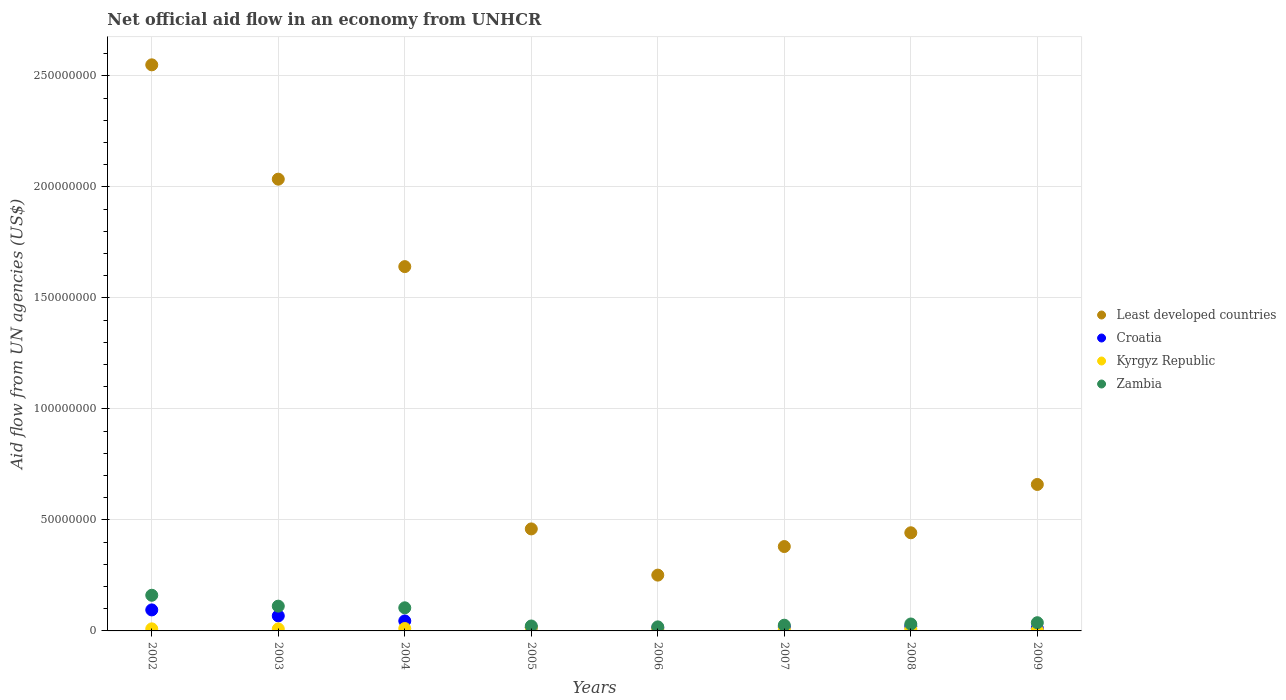How many different coloured dotlines are there?
Your answer should be very brief. 4. Is the number of dotlines equal to the number of legend labels?
Offer a very short reply. Yes. What is the net official aid flow in Kyrgyz Republic in 2002?
Your response must be concise. 9.30e+05. Across all years, what is the maximum net official aid flow in Least developed countries?
Your answer should be very brief. 2.55e+08. What is the total net official aid flow in Least developed countries in the graph?
Keep it short and to the point. 8.42e+08. What is the difference between the net official aid flow in Zambia in 2003 and that in 2009?
Your response must be concise. 7.46e+06. What is the difference between the net official aid flow in Croatia in 2002 and the net official aid flow in Zambia in 2009?
Your response must be concise. 5.76e+06. What is the average net official aid flow in Kyrgyz Republic per year?
Offer a terse response. 8.65e+05. In the year 2006, what is the difference between the net official aid flow in Least developed countries and net official aid flow in Croatia?
Make the answer very short. 2.38e+07. In how many years, is the net official aid flow in Croatia greater than 90000000 US$?
Keep it short and to the point. 0. What is the ratio of the net official aid flow in Least developed countries in 2008 to that in 2009?
Offer a very short reply. 0.67. Is the net official aid flow in Kyrgyz Republic in 2002 less than that in 2009?
Make the answer very short. No. Is the difference between the net official aid flow in Least developed countries in 2003 and 2006 greater than the difference between the net official aid flow in Croatia in 2003 and 2006?
Your answer should be compact. Yes. What is the difference between the highest and the second highest net official aid flow in Croatia?
Your response must be concise. 2.69e+06. What is the difference between the highest and the lowest net official aid flow in Least developed countries?
Your answer should be very brief. 2.30e+08. In how many years, is the net official aid flow in Least developed countries greater than the average net official aid flow in Least developed countries taken over all years?
Ensure brevity in your answer.  3. Is the sum of the net official aid flow in Zambia in 2005 and 2007 greater than the maximum net official aid flow in Croatia across all years?
Ensure brevity in your answer.  No. Does the net official aid flow in Least developed countries monotonically increase over the years?
Offer a very short reply. No. Is the net official aid flow in Croatia strictly less than the net official aid flow in Kyrgyz Republic over the years?
Your answer should be compact. No. How many years are there in the graph?
Keep it short and to the point. 8. What is the difference between two consecutive major ticks on the Y-axis?
Provide a short and direct response. 5.00e+07. Where does the legend appear in the graph?
Offer a terse response. Center right. How are the legend labels stacked?
Ensure brevity in your answer.  Vertical. What is the title of the graph?
Provide a succinct answer. Net official aid flow in an economy from UNHCR. Does "Bangladesh" appear as one of the legend labels in the graph?
Your response must be concise. No. What is the label or title of the X-axis?
Keep it short and to the point. Years. What is the label or title of the Y-axis?
Offer a very short reply. Aid flow from UN agencies (US$). What is the Aid flow from UN agencies (US$) of Least developed countries in 2002?
Keep it short and to the point. 2.55e+08. What is the Aid flow from UN agencies (US$) in Croatia in 2002?
Make the answer very short. 9.46e+06. What is the Aid flow from UN agencies (US$) in Kyrgyz Republic in 2002?
Keep it short and to the point. 9.30e+05. What is the Aid flow from UN agencies (US$) in Zambia in 2002?
Keep it short and to the point. 1.61e+07. What is the Aid flow from UN agencies (US$) of Least developed countries in 2003?
Your answer should be compact. 2.03e+08. What is the Aid flow from UN agencies (US$) of Croatia in 2003?
Ensure brevity in your answer.  6.77e+06. What is the Aid flow from UN agencies (US$) of Kyrgyz Republic in 2003?
Provide a succinct answer. 9.00e+05. What is the Aid flow from UN agencies (US$) in Zambia in 2003?
Make the answer very short. 1.12e+07. What is the Aid flow from UN agencies (US$) in Least developed countries in 2004?
Offer a terse response. 1.64e+08. What is the Aid flow from UN agencies (US$) in Croatia in 2004?
Provide a short and direct response. 4.50e+06. What is the Aid flow from UN agencies (US$) of Kyrgyz Republic in 2004?
Keep it short and to the point. 1.08e+06. What is the Aid flow from UN agencies (US$) in Zambia in 2004?
Your response must be concise. 1.04e+07. What is the Aid flow from UN agencies (US$) in Least developed countries in 2005?
Ensure brevity in your answer.  4.59e+07. What is the Aid flow from UN agencies (US$) in Croatia in 2005?
Your answer should be very brief. 1.61e+06. What is the Aid flow from UN agencies (US$) in Kyrgyz Republic in 2005?
Keep it short and to the point. 1.47e+06. What is the Aid flow from UN agencies (US$) in Zambia in 2005?
Make the answer very short. 2.22e+06. What is the Aid flow from UN agencies (US$) in Least developed countries in 2006?
Ensure brevity in your answer.  2.51e+07. What is the Aid flow from UN agencies (US$) in Croatia in 2006?
Provide a succinct answer. 1.38e+06. What is the Aid flow from UN agencies (US$) in Kyrgyz Republic in 2006?
Your response must be concise. 7.10e+05. What is the Aid flow from UN agencies (US$) of Zambia in 2006?
Offer a very short reply. 1.82e+06. What is the Aid flow from UN agencies (US$) of Least developed countries in 2007?
Make the answer very short. 3.80e+07. What is the Aid flow from UN agencies (US$) in Croatia in 2007?
Offer a very short reply. 1.78e+06. What is the Aid flow from UN agencies (US$) of Kyrgyz Republic in 2007?
Your answer should be very brief. 6.50e+05. What is the Aid flow from UN agencies (US$) in Zambia in 2007?
Keep it short and to the point. 2.58e+06. What is the Aid flow from UN agencies (US$) of Least developed countries in 2008?
Offer a very short reply. 4.42e+07. What is the Aid flow from UN agencies (US$) of Croatia in 2008?
Keep it short and to the point. 2.11e+06. What is the Aid flow from UN agencies (US$) of Kyrgyz Republic in 2008?
Provide a short and direct response. 8.20e+05. What is the Aid flow from UN agencies (US$) of Zambia in 2008?
Make the answer very short. 3.12e+06. What is the Aid flow from UN agencies (US$) in Least developed countries in 2009?
Ensure brevity in your answer.  6.60e+07. What is the Aid flow from UN agencies (US$) of Croatia in 2009?
Provide a short and direct response. 1.18e+06. What is the Aid flow from UN agencies (US$) in Zambia in 2009?
Provide a short and direct response. 3.70e+06. Across all years, what is the maximum Aid flow from UN agencies (US$) of Least developed countries?
Make the answer very short. 2.55e+08. Across all years, what is the maximum Aid flow from UN agencies (US$) in Croatia?
Keep it short and to the point. 9.46e+06. Across all years, what is the maximum Aid flow from UN agencies (US$) in Kyrgyz Republic?
Give a very brief answer. 1.47e+06. Across all years, what is the maximum Aid flow from UN agencies (US$) in Zambia?
Make the answer very short. 1.61e+07. Across all years, what is the minimum Aid flow from UN agencies (US$) in Least developed countries?
Your answer should be compact. 2.51e+07. Across all years, what is the minimum Aid flow from UN agencies (US$) in Croatia?
Provide a succinct answer. 1.18e+06. Across all years, what is the minimum Aid flow from UN agencies (US$) of Kyrgyz Republic?
Your answer should be compact. 3.60e+05. Across all years, what is the minimum Aid flow from UN agencies (US$) in Zambia?
Offer a terse response. 1.82e+06. What is the total Aid flow from UN agencies (US$) of Least developed countries in the graph?
Your answer should be compact. 8.42e+08. What is the total Aid flow from UN agencies (US$) in Croatia in the graph?
Make the answer very short. 2.88e+07. What is the total Aid flow from UN agencies (US$) of Kyrgyz Republic in the graph?
Keep it short and to the point. 6.92e+06. What is the total Aid flow from UN agencies (US$) of Zambia in the graph?
Your response must be concise. 5.11e+07. What is the difference between the Aid flow from UN agencies (US$) in Least developed countries in 2002 and that in 2003?
Your answer should be very brief. 5.15e+07. What is the difference between the Aid flow from UN agencies (US$) of Croatia in 2002 and that in 2003?
Your response must be concise. 2.69e+06. What is the difference between the Aid flow from UN agencies (US$) in Kyrgyz Republic in 2002 and that in 2003?
Give a very brief answer. 3.00e+04. What is the difference between the Aid flow from UN agencies (US$) of Zambia in 2002 and that in 2003?
Ensure brevity in your answer.  4.90e+06. What is the difference between the Aid flow from UN agencies (US$) in Least developed countries in 2002 and that in 2004?
Make the answer very short. 9.09e+07. What is the difference between the Aid flow from UN agencies (US$) in Croatia in 2002 and that in 2004?
Offer a very short reply. 4.96e+06. What is the difference between the Aid flow from UN agencies (US$) of Kyrgyz Republic in 2002 and that in 2004?
Provide a short and direct response. -1.50e+05. What is the difference between the Aid flow from UN agencies (US$) in Zambia in 2002 and that in 2004?
Make the answer very short. 5.65e+06. What is the difference between the Aid flow from UN agencies (US$) of Least developed countries in 2002 and that in 2005?
Offer a terse response. 2.09e+08. What is the difference between the Aid flow from UN agencies (US$) of Croatia in 2002 and that in 2005?
Give a very brief answer. 7.85e+06. What is the difference between the Aid flow from UN agencies (US$) in Kyrgyz Republic in 2002 and that in 2005?
Your answer should be compact. -5.40e+05. What is the difference between the Aid flow from UN agencies (US$) in Zambia in 2002 and that in 2005?
Provide a short and direct response. 1.38e+07. What is the difference between the Aid flow from UN agencies (US$) of Least developed countries in 2002 and that in 2006?
Offer a very short reply. 2.30e+08. What is the difference between the Aid flow from UN agencies (US$) in Croatia in 2002 and that in 2006?
Ensure brevity in your answer.  8.08e+06. What is the difference between the Aid flow from UN agencies (US$) in Kyrgyz Republic in 2002 and that in 2006?
Offer a very short reply. 2.20e+05. What is the difference between the Aid flow from UN agencies (US$) of Zambia in 2002 and that in 2006?
Ensure brevity in your answer.  1.42e+07. What is the difference between the Aid flow from UN agencies (US$) of Least developed countries in 2002 and that in 2007?
Keep it short and to the point. 2.17e+08. What is the difference between the Aid flow from UN agencies (US$) in Croatia in 2002 and that in 2007?
Offer a very short reply. 7.68e+06. What is the difference between the Aid flow from UN agencies (US$) of Zambia in 2002 and that in 2007?
Make the answer very short. 1.35e+07. What is the difference between the Aid flow from UN agencies (US$) in Least developed countries in 2002 and that in 2008?
Your response must be concise. 2.11e+08. What is the difference between the Aid flow from UN agencies (US$) in Croatia in 2002 and that in 2008?
Your answer should be very brief. 7.35e+06. What is the difference between the Aid flow from UN agencies (US$) of Kyrgyz Republic in 2002 and that in 2008?
Provide a succinct answer. 1.10e+05. What is the difference between the Aid flow from UN agencies (US$) of Zambia in 2002 and that in 2008?
Your answer should be very brief. 1.29e+07. What is the difference between the Aid flow from UN agencies (US$) of Least developed countries in 2002 and that in 2009?
Your response must be concise. 1.89e+08. What is the difference between the Aid flow from UN agencies (US$) in Croatia in 2002 and that in 2009?
Give a very brief answer. 8.28e+06. What is the difference between the Aid flow from UN agencies (US$) of Kyrgyz Republic in 2002 and that in 2009?
Ensure brevity in your answer.  5.70e+05. What is the difference between the Aid flow from UN agencies (US$) in Zambia in 2002 and that in 2009?
Your answer should be very brief. 1.24e+07. What is the difference between the Aid flow from UN agencies (US$) in Least developed countries in 2003 and that in 2004?
Your answer should be compact. 3.94e+07. What is the difference between the Aid flow from UN agencies (US$) of Croatia in 2003 and that in 2004?
Offer a terse response. 2.27e+06. What is the difference between the Aid flow from UN agencies (US$) of Zambia in 2003 and that in 2004?
Give a very brief answer. 7.50e+05. What is the difference between the Aid flow from UN agencies (US$) in Least developed countries in 2003 and that in 2005?
Offer a terse response. 1.58e+08. What is the difference between the Aid flow from UN agencies (US$) in Croatia in 2003 and that in 2005?
Give a very brief answer. 5.16e+06. What is the difference between the Aid flow from UN agencies (US$) in Kyrgyz Republic in 2003 and that in 2005?
Keep it short and to the point. -5.70e+05. What is the difference between the Aid flow from UN agencies (US$) of Zambia in 2003 and that in 2005?
Provide a succinct answer. 8.94e+06. What is the difference between the Aid flow from UN agencies (US$) in Least developed countries in 2003 and that in 2006?
Your answer should be very brief. 1.78e+08. What is the difference between the Aid flow from UN agencies (US$) of Croatia in 2003 and that in 2006?
Make the answer very short. 5.39e+06. What is the difference between the Aid flow from UN agencies (US$) of Zambia in 2003 and that in 2006?
Provide a succinct answer. 9.34e+06. What is the difference between the Aid flow from UN agencies (US$) in Least developed countries in 2003 and that in 2007?
Ensure brevity in your answer.  1.65e+08. What is the difference between the Aid flow from UN agencies (US$) of Croatia in 2003 and that in 2007?
Your response must be concise. 4.99e+06. What is the difference between the Aid flow from UN agencies (US$) in Kyrgyz Republic in 2003 and that in 2007?
Make the answer very short. 2.50e+05. What is the difference between the Aid flow from UN agencies (US$) in Zambia in 2003 and that in 2007?
Offer a terse response. 8.58e+06. What is the difference between the Aid flow from UN agencies (US$) in Least developed countries in 2003 and that in 2008?
Provide a short and direct response. 1.59e+08. What is the difference between the Aid flow from UN agencies (US$) of Croatia in 2003 and that in 2008?
Offer a very short reply. 4.66e+06. What is the difference between the Aid flow from UN agencies (US$) in Zambia in 2003 and that in 2008?
Offer a very short reply. 8.04e+06. What is the difference between the Aid flow from UN agencies (US$) of Least developed countries in 2003 and that in 2009?
Offer a terse response. 1.37e+08. What is the difference between the Aid flow from UN agencies (US$) of Croatia in 2003 and that in 2009?
Keep it short and to the point. 5.59e+06. What is the difference between the Aid flow from UN agencies (US$) in Kyrgyz Republic in 2003 and that in 2009?
Give a very brief answer. 5.40e+05. What is the difference between the Aid flow from UN agencies (US$) in Zambia in 2003 and that in 2009?
Offer a terse response. 7.46e+06. What is the difference between the Aid flow from UN agencies (US$) of Least developed countries in 2004 and that in 2005?
Give a very brief answer. 1.18e+08. What is the difference between the Aid flow from UN agencies (US$) of Croatia in 2004 and that in 2005?
Keep it short and to the point. 2.89e+06. What is the difference between the Aid flow from UN agencies (US$) of Kyrgyz Republic in 2004 and that in 2005?
Provide a succinct answer. -3.90e+05. What is the difference between the Aid flow from UN agencies (US$) in Zambia in 2004 and that in 2005?
Provide a succinct answer. 8.19e+06. What is the difference between the Aid flow from UN agencies (US$) in Least developed countries in 2004 and that in 2006?
Provide a succinct answer. 1.39e+08. What is the difference between the Aid flow from UN agencies (US$) of Croatia in 2004 and that in 2006?
Provide a short and direct response. 3.12e+06. What is the difference between the Aid flow from UN agencies (US$) of Zambia in 2004 and that in 2006?
Keep it short and to the point. 8.59e+06. What is the difference between the Aid flow from UN agencies (US$) of Least developed countries in 2004 and that in 2007?
Your response must be concise. 1.26e+08. What is the difference between the Aid flow from UN agencies (US$) in Croatia in 2004 and that in 2007?
Offer a very short reply. 2.72e+06. What is the difference between the Aid flow from UN agencies (US$) in Zambia in 2004 and that in 2007?
Keep it short and to the point. 7.83e+06. What is the difference between the Aid flow from UN agencies (US$) in Least developed countries in 2004 and that in 2008?
Make the answer very short. 1.20e+08. What is the difference between the Aid flow from UN agencies (US$) in Croatia in 2004 and that in 2008?
Your response must be concise. 2.39e+06. What is the difference between the Aid flow from UN agencies (US$) of Kyrgyz Republic in 2004 and that in 2008?
Make the answer very short. 2.60e+05. What is the difference between the Aid flow from UN agencies (US$) of Zambia in 2004 and that in 2008?
Give a very brief answer. 7.29e+06. What is the difference between the Aid flow from UN agencies (US$) in Least developed countries in 2004 and that in 2009?
Give a very brief answer. 9.81e+07. What is the difference between the Aid flow from UN agencies (US$) of Croatia in 2004 and that in 2009?
Your answer should be very brief. 3.32e+06. What is the difference between the Aid flow from UN agencies (US$) in Kyrgyz Republic in 2004 and that in 2009?
Offer a terse response. 7.20e+05. What is the difference between the Aid flow from UN agencies (US$) in Zambia in 2004 and that in 2009?
Ensure brevity in your answer.  6.71e+06. What is the difference between the Aid flow from UN agencies (US$) of Least developed countries in 2005 and that in 2006?
Provide a short and direct response. 2.08e+07. What is the difference between the Aid flow from UN agencies (US$) in Kyrgyz Republic in 2005 and that in 2006?
Provide a short and direct response. 7.60e+05. What is the difference between the Aid flow from UN agencies (US$) in Least developed countries in 2005 and that in 2007?
Offer a terse response. 7.94e+06. What is the difference between the Aid flow from UN agencies (US$) of Croatia in 2005 and that in 2007?
Provide a succinct answer. -1.70e+05. What is the difference between the Aid flow from UN agencies (US$) of Kyrgyz Republic in 2005 and that in 2007?
Provide a succinct answer. 8.20e+05. What is the difference between the Aid flow from UN agencies (US$) in Zambia in 2005 and that in 2007?
Your response must be concise. -3.60e+05. What is the difference between the Aid flow from UN agencies (US$) of Least developed countries in 2005 and that in 2008?
Keep it short and to the point. 1.74e+06. What is the difference between the Aid flow from UN agencies (US$) in Croatia in 2005 and that in 2008?
Your response must be concise. -5.00e+05. What is the difference between the Aid flow from UN agencies (US$) of Kyrgyz Republic in 2005 and that in 2008?
Give a very brief answer. 6.50e+05. What is the difference between the Aid flow from UN agencies (US$) of Zambia in 2005 and that in 2008?
Provide a succinct answer. -9.00e+05. What is the difference between the Aid flow from UN agencies (US$) of Least developed countries in 2005 and that in 2009?
Give a very brief answer. -2.00e+07. What is the difference between the Aid flow from UN agencies (US$) of Kyrgyz Republic in 2005 and that in 2009?
Keep it short and to the point. 1.11e+06. What is the difference between the Aid flow from UN agencies (US$) of Zambia in 2005 and that in 2009?
Provide a short and direct response. -1.48e+06. What is the difference between the Aid flow from UN agencies (US$) in Least developed countries in 2006 and that in 2007?
Offer a very short reply. -1.29e+07. What is the difference between the Aid flow from UN agencies (US$) in Croatia in 2006 and that in 2007?
Ensure brevity in your answer.  -4.00e+05. What is the difference between the Aid flow from UN agencies (US$) in Kyrgyz Republic in 2006 and that in 2007?
Provide a succinct answer. 6.00e+04. What is the difference between the Aid flow from UN agencies (US$) of Zambia in 2006 and that in 2007?
Provide a short and direct response. -7.60e+05. What is the difference between the Aid flow from UN agencies (US$) of Least developed countries in 2006 and that in 2008?
Ensure brevity in your answer.  -1.91e+07. What is the difference between the Aid flow from UN agencies (US$) in Croatia in 2006 and that in 2008?
Ensure brevity in your answer.  -7.30e+05. What is the difference between the Aid flow from UN agencies (US$) in Kyrgyz Republic in 2006 and that in 2008?
Your answer should be very brief. -1.10e+05. What is the difference between the Aid flow from UN agencies (US$) in Zambia in 2006 and that in 2008?
Keep it short and to the point. -1.30e+06. What is the difference between the Aid flow from UN agencies (US$) in Least developed countries in 2006 and that in 2009?
Give a very brief answer. -4.08e+07. What is the difference between the Aid flow from UN agencies (US$) in Croatia in 2006 and that in 2009?
Your response must be concise. 2.00e+05. What is the difference between the Aid flow from UN agencies (US$) in Zambia in 2006 and that in 2009?
Offer a very short reply. -1.88e+06. What is the difference between the Aid flow from UN agencies (US$) of Least developed countries in 2007 and that in 2008?
Your answer should be compact. -6.20e+06. What is the difference between the Aid flow from UN agencies (US$) in Croatia in 2007 and that in 2008?
Give a very brief answer. -3.30e+05. What is the difference between the Aid flow from UN agencies (US$) of Zambia in 2007 and that in 2008?
Give a very brief answer. -5.40e+05. What is the difference between the Aid flow from UN agencies (US$) in Least developed countries in 2007 and that in 2009?
Offer a terse response. -2.80e+07. What is the difference between the Aid flow from UN agencies (US$) in Kyrgyz Republic in 2007 and that in 2009?
Give a very brief answer. 2.90e+05. What is the difference between the Aid flow from UN agencies (US$) of Zambia in 2007 and that in 2009?
Give a very brief answer. -1.12e+06. What is the difference between the Aid flow from UN agencies (US$) in Least developed countries in 2008 and that in 2009?
Ensure brevity in your answer.  -2.18e+07. What is the difference between the Aid flow from UN agencies (US$) in Croatia in 2008 and that in 2009?
Offer a terse response. 9.30e+05. What is the difference between the Aid flow from UN agencies (US$) in Zambia in 2008 and that in 2009?
Make the answer very short. -5.80e+05. What is the difference between the Aid flow from UN agencies (US$) of Least developed countries in 2002 and the Aid flow from UN agencies (US$) of Croatia in 2003?
Give a very brief answer. 2.48e+08. What is the difference between the Aid flow from UN agencies (US$) of Least developed countries in 2002 and the Aid flow from UN agencies (US$) of Kyrgyz Republic in 2003?
Give a very brief answer. 2.54e+08. What is the difference between the Aid flow from UN agencies (US$) of Least developed countries in 2002 and the Aid flow from UN agencies (US$) of Zambia in 2003?
Provide a succinct answer. 2.44e+08. What is the difference between the Aid flow from UN agencies (US$) in Croatia in 2002 and the Aid flow from UN agencies (US$) in Kyrgyz Republic in 2003?
Provide a short and direct response. 8.56e+06. What is the difference between the Aid flow from UN agencies (US$) of Croatia in 2002 and the Aid flow from UN agencies (US$) of Zambia in 2003?
Keep it short and to the point. -1.70e+06. What is the difference between the Aid flow from UN agencies (US$) of Kyrgyz Republic in 2002 and the Aid flow from UN agencies (US$) of Zambia in 2003?
Ensure brevity in your answer.  -1.02e+07. What is the difference between the Aid flow from UN agencies (US$) of Least developed countries in 2002 and the Aid flow from UN agencies (US$) of Croatia in 2004?
Keep it short and to the point. 2.50e+08. What is the difference between the Aid flow from UN agencies (US$) of Least developed countries in 2002 and the Aid flow from UN agencies (US$) of Kyrgyz Republic in 2004?
Your response must be concise. 2.54e+08. What is the difference between the Aid flow from UN agencies (US$) of Least developed countries in 2002 and the Aid flow from UN agencies (US$) of Zambia in 2004?
Ensure brevity in your answer.  2.45e+08. What is the difference between the Aid flow from UN agencies (US$) of Croatia in 2002 and the Aid flow from UN agencies (US$) of Kyrgyz Republic in 2004?
Your response must be concise. 8.38e+06. What is the difference between the Aid flow from UN agencies (US$) in Croatia in 2002 and the Aid flow from UN agencies (US$) in Zambia in 2004?
Provide a short and direct response. -9.50e+05. What is the difference between the Aid flow from UN agencies (US$) of Kyrgyz Republic in 2002 and the Aid flow from UN agencies (US$) of Zambia in 2004?
Make the answer very short. -9.48e+06. What is the difference between the Aid flow from UN agencies (US$) in Least developed countries in 2002 and the Aid flow from UN agencies (US$) in Croatia in 2005?
Ensure brevity in your answer.  2.53e+08. What is the difference between the Aid flow from UN agencies (US$) of Least developed countries in 2002 and the Aid flow from UN agencies (US$) of Kyrgyz Republic in 2005?
Your answer should be very brief. 2.53e+08. What is the difference between the Aid flow from UN agencies (US$) of Least developed countries in 2002 and the Aid flow from UN agencies (US$) of Zambia in 2005?
Make the answer very short. 2.53e+08. What is the difference between the Aid flow from UN agencies (US$) in Croatia in 2002 and the Aid flow from UN agencies (US$) in Kyrgyz Republic in 2005?
Make the answer very short. 7.99e+06. What is the difference between the Aid flow from UN agencies (US$) of Croatia in 2002 and the Aid flow from UN agencies (US$) of Zambia in 2005?
Provide a succinct answer. 7.24e+06. What is the difference between the Aid flow from UN agencies (US$) in Kyrgyz Republic in 2002 and the Aid flow from UN agencies (US$) in Zambia in 2005?
Ensure brevity in your answer.  -1.29e+06. What is the difference between the Aid flow from UN agencies (US$) of Least developed countries in 2002 and the Aid flow from UN agencies (US$) of Croatia in 2006?
Give a very brief answer. 2.54e+08. What is the difference between the Aid flow from UN agencies (US$) in Least developed countries in 2002 and the Aid flow from UN agencies (US$) in Kyrgyz Republic in 2006?
Provide a short and direct response. 2.54e+08. What is the difference between the Aid flow from UN agencies (US$) of Least developed countries in 2002 and the Aid flow from UN agencies (US$) of Zambia in 2006?
Provide a succinct answer. 2.53e+08. What is the difference between the Aid flow from UN agencies (US$) in Croatia in 2002 and the Aid flow from UN agencies (US$) in Kyrgyz Republic in 2006?
Make the answer very short. 8.75e+06. What is the difference between the Aid flow from UN agencies (US$) in Croatia in 2002 and the Aid flow from UN agencies (US$) in Zambia in 2006?
Offer a very short reply. 7.64e+06. What is the difference between the Aid flow from UN agencies (US$) in Kyrgyz Republic in 2002 and the Aid flow from UN agencies (US$) in Zambia in 2006?
Your answer should be compact. -8.90e+05. What is the difference between the Aid flow from UN agencies (US$) of Least developed countries in 2002 and the Aid flow from UN agencies (US$) of Croatia in 2007?
Provide a short and direct response. 2.53e+08. What is the difference between the Aid flow from UN agencies (US$) in Least developed countries in 2002 and the Aid flow from UN agencies (US$) in Kyrgyz Republic in 2007?
Give a very brief answer. 2.54e+08. What is the difference between the Aid flow from UN agencies (US$) of Least developed countries in 2002 and the Aid flow from UN agencies (US$) of Zambia in 2007?
Your response must be concise. 2.52e+08. What is the difference between the Aid flow from UN agencies (US$) in Croatia in 2002 and the Aid flow from UN agencies (US$) in Kyrgyz Republic in 2007?
Give a very brief answer. 8.81e+06. What is the difference between the Aid flow from UN agencies (US$) in Croatia in 2002 and the Aid flow from UN agencies (US$) in Zambia in 2007?
Provide a succinct answer. 6.88e+06. What is the difference between the Aid flow from UN agencies (US$) of Kyrgyz Republic in 2002 and the Aid flow from UN agencies (US$) of Zambia in 2007?
Make the answer very short. -1.65e+06. What is the difference between the Aid flow from UN agencies (US$) of Least developed countries in 2002 and the Aid flow from UN agencies (US$) of Croatia in 2008?
Ensure brevity in your answer.  2.53e+08. What is the difference between the Aid flow from UN agencies (US$) in Least developed countries in 2002 and the Aid flow from UN agencies (US$) in Kyrgyz Republic in 2008?
Keep it short and to the point. 2.54e+08. What is the difference between the Aid flow from UN agencies (US$) of Least developed countries in 2002 and the Aid flow from UN agencies (US$) of Zambia in 2008?
Your answer should be compact. 2.52e+08. What is the difference between the Aid flow from UN agencies (US$) in Croatia in 2002 and the Aid flow from UN agencies (US$) in Kyrgyz Republic in 2008?
Your answer should be compact. 8.64e+06. What is the difference between the Aid flow from UN agencies (US$) of Croatia in 2002 and the Aid flow from UN agencies (US$) of Zambia in 2008?
Offer a very short reply. 6.34e+06. What is the difference between the Aid flow from UN agencies (US$) in Kyrgyz Republic in 2002 and the Aid flow from UN agencies (US$) in Zambia in 2008?
Keep it short and to the point. -2.19e+06. What is the difference between the Aid flow from UN agencies (US$) of Least developed countries in 2002 and the Aid flow from UN agencies (US$) of Croatia in 2009?
Provide a short and direct response. 2.54e+08. What is the difference between the Aid flow from UN agencies (US$) in Least developed countries in 2002 and the Aid flow from UN agencies (US$) in Kyrgyz Republic in 2009?
Your answer should be compact. 2.55e+08. What is the difference between the Aid flow from UN agencies (US$) of Least developed countries in 2002 and the Aid flow from UN agencies (US$) of Zambia in 2009?
Ensure brevity in your answer.  2.51e+08. What is the difference between the Aid flow from UN agencies (US$) of Croatia in 2002 and the Aid flow from UN agencies (US$) of Kyrgyz Republic in 2009?
Offer a terse response. 9.10e+06. What is the difference between the Aid flow from UN agencies (US$) of Croatia in 2002 and the Aid flow from UN agencies (US$) of Zambia in 2009?
Give a very brief answer. 5.76e+06. What is the difference between the Aid flow from UN agencies (US$) in Kyrgyz Republic in 2002 and the Aid flow from UN agencies (US$) in Zambia in 2009?
Provide a short and direct response. -2.77e+06. What is the difference between the Aid flow from UN agencies (US$) in Least developed countries in 2003 and the Aid flow from UN agencies (US$) in Croatia in 2004?
Your response must be concise. 1.99e+08. What is the difference between the Aid flow from UN agencies (US$) of Least developed countries in 2003 and the Aid flow from UN agencies (US$) of Kyrgyz Republic in 2004?
Provide a short and direct response. 2.02e+08. What is the difference between the Aid flow from UN agencies (US$) of Least developed countries in 2003 and the Aid flow from UN agencies (US$) of Zambia in 2004?
Make the answer very short. 1.93e+08. What is the difference between the Aid flow from UN agencies (US$) of Croatia in 2003 and the Aid flow from UN agencies (US$) of Kyrgyz Republic in 2004?
Offer a terse response. 5.69e+06. What is the difference between the Aid flow from UN agencies (US$) in Croatia in 2003 and the Aid flow from UN agencies (US$) in Zambia in 2004?
Your response must be concise. -3.64e+06. What is the difference between the Aid flow from UN agencies (US$) of Kyrgyz Republic in 2003 and the Aid flow from UN agencies (US$) of Zambia in 2004?
Keep it short and to the point. -9.51e+06. What is the difference between the Aid flow from UN agencies (US$) of Least developed countries in 2003 and the Aid flow from UN agencies (US$) of Croatia in 2005?
Keep it short and to the point. 2.02e+08. What is the difference between the Aid flow from UN agencies (US$) of Least developed countries in 2003 and the Aid flow from UN agencies (US$) of Kyrgyz Republic in 2005?
Your answer should be compact. 2.02e+08. What is the difference between the Aid flow from UN agencies (US$) of Least developed countries in 2003 and the Aid flow from UN agencies (US$) of Zambia in 2005?
Make the answer very short. 2.01e+08. What is the difference between the Aid flow from UN agencies (US$) in Croatia in 2003 and the Aid flow from UN agencies (US$) in Kyrgyz Republic in 2005?
Ensure brevity in your answer.  5.30e+06. What is the difference between the Aid flow from UN agencies (US$) of Croatia in 2003 and the Aid flow from UN agencies (US$) of Zambia in 2005?
Provide a short and direct response. 4.55e+06. What is the difference between the Aid flow from UN agencies (US$) in Kyrgyz Republic in 2003 and the Aid flow from UN agencies (US$) in Zambia in 2005?
Offer a very short reply. -1.32e+06. What is the difference between the Aid flow from UN agencies (US$) of Least developed countries in 2003 and the Aid flow from UN agencies (US$) of Croatia in 2006?
Give a very brief answer. 2.02e+08. What is the difference between the Aid flow from UN agencies (US$) of Least developed countries in 2003 and the Aid flow from UN agencies (US$) of Kyrgyz Republic in 2006?
Your response must be concise. 2.03e+08. What is the difference between the Aid flow from UN agencies (US$) of Least developed countries in 2003 and the Aid flow from UN agencies (US$) of Zambia in 2006?
Your answer should be compact. 2.02e+08. What is the difference between the Aid flow from UN agencies (US$) of Croatia in 2003 and the Aid flow from UN agencies (US$) of Kyrgyz Republic in 2006?
Your response must be concise. 6.06e+06. What is the difference between the Aid flow from UN agencies (US$) of Croatia in 2003 and the Aid flow from UN agencies (US$) of Zambia in 2006?
Offer a very short reply. 4.95e+06. What is the difference between the Aid flow from UN agencies (US$) of Kyrgyz Republic in 2003 and the Aid flow from UN agencies (US$) of Zambia in 2006?
Provide a succinct answer. -9.20e+05. What is the difference between the Aid flow from UN agencies (US$) of Least developed countries in 2003 and the Aid flow from UN agencies (US$) of Croatia in 2007?
Provide a succinct answer. 2.02e+08. What is the difference between the Aid flow from UN agencies (US$) of Least developed countries in 2003 and the Aid flow from UN agencies (US$) of Kyrgyz Republic in 2007?
Provide a succinct answer. 2.03e+08. What is the difference between the Aid flow from UN agencies (US$) in Least developed countries in 2003 and the Aid flow from UN agencies (US$) in Zambia in 2007?
Offer a terse response. 2.01e+08. What is the difference between the Aid flow from UN agencies (US$) of Croatia in 2003 and the Aid flow from UN agencies (US$) of Kyrgyz Republic in 2007?
Offer a terse response. 6.12e+06. What is the difference between the Aid flow from UN agencies (US$) of Croatia in 2003 and the Aid flow from UN agencies (US$) of Zambia in 2007?
Ensure brevity in your answer.  4.19e+06. What is the difference between the Aid flow from UN agencies (US$) of Kyrgyz Republic in 2003 and the Aid flow from UN agencies (US$) of Zambia in 2007?
Give a very brief answer. -1.68e+06. What is the difference between the Aid flow from UN agencies (US$) in Least developed countries in 2003 and the Aid flow from UN agencies (US$) in Croatia in 2008?
Provide a short and direct response. 2.01e+08. What is the difference between the Aid flow from UN agencies (US$) in Least developed countries in 2003 and the Aid flow from UN agencies (US$) in Kyrgyz Republic in 2008?
Your answer should be very brief. 2.03e+08. What is the difference between the Aid flow from UN agencies (US$) in Least developed countries in 2003 and the Aid flow from UN agencies (US$) in Zambia in 2008?
Your response must be concise. 2.00e+08. What is the difference between the Aid flow from UN agencies (US$) of Croatia in 2003 and the Aid flow from UN agencies (US$) of Kyrgyz Republic in 2008?
Your response must be concise. 5.95e+06. What is the difference between the Aid flow from UN agencies (US$) in Croatia in 2003 and the Aid flow from UN agencies (US$) in Zambia in 2008?
Give a very brief answer. 3.65e+06. What is the difference between the Aid flow from UN agencies (US$) in Kyrgyz Republic in 2003 and the Aid flow from UN agencies (US$) in Zambia in 2008?
Offer a very short reply. -2.22e+06. What is the difference between the Aid flow from UN agencies (US$) of Least developed countries in 2003 and the Aid flow from UN agencies (US$) of Croatia in 2009?
Provide a succinct answer. 2.02e+08. What is the difference between the Aid flow from UN agencies (US$) of Least developed countries in 2003 and the Aid flow from UN agencies (US$) of Kyrgyz Republic in 2009?
Offer a terse response. 2.03e+08. What is the difference between the Aid flow from UN agencies (US$) in Least developed countries in 2003 and the Aid flow from UN agencies (US$) in Zambia in 2009?
Ensure brevity in your answer.  2.00e+08. What is the difference between the Aid flow from UN agencies (US$) in Croatia in 2003 and the Aid flow from UN agencies (US$) in Kyrgyz Republic in 2009?
Offer a very short reply. 6.41e+06. What is the difference between the Aid flow from UN agencies (US$) in Croatia in 2003 and the Aid flow from UN agencies (US$) in Zambia in 2009?
Give a very brief answer. 3.07e+06. What is the difference between the Aid flow from UN agencies (US$) in Kyrgyz Republic in 2003 and the Aid flow from UN agencies (US$) in Zambia in 2009?
Give a very brief answer. -2.80e+06. What is the difference between the Aid flow from UN agencies (US$) of Least developed countries in 2004 and the Aid flow from UN agencies (US$) of Croatia in 2005?
Your answer should be very brief. 1.62e+08. What is the difference between the Aid flow from UN agencies (US$) in Least developed countries in 2004 and the Aid flow from UN agencies (US$) in Kyrgyz Republic in 2005?
Offer a very short reply. 1.63e+08. What is the difference between the Aid flow from UN agencies (US$) in Least developed countries in 2004 and the Aid flow from UN agencies (US$) in Zambia in 2005?
Provide a succinct answer. 1.62e+08. What is the difference between the Aid flow from UN agencies (US$) in Croatia in 2004 and the Aid flow from UN agencies (US$) in Kyrgyz Republic in 2005?
Your answer should be very brief. 3.03e+06. What is the difference between the Aid flow from UN agencies (US$) of Croatia in 2004 and the Aid flow from UN agencies (US$) of Zambia in 2005?
Your answer should be very brief. 2.28e+06. What is the difference between the Aid flow from UN agencies (US$) of Kyrgyz Republic in 2004 and the Aid flow from UN agencies (US$) of Zambia in 2005?
Your answer should be very brief. -1.14e+06. What is the difference between the Aid flow from UN agencies (US$) of Least developed countries in 2004 and the Aid flow from UN agencies (US$) of Croatia in 2006?
Ensure brevity in your answer.  1.63e+08. What is the difference between the Aid flow from UN agencies (US$) of Least developed countries in 2004 and the Aid flow from UN agencies (US$) of Kyrgyz Republic in 2006?
Offer a terse response. 1.63e+08. What is the difference between the Aid flow from UN agencies (US$) in Least developed countries in 2004 and the Aid flow from UN agencies (US$) in Zambia in 2006?
Your answer should be compact. 1.62e+08. What is the difference between the Aid flow from UN agencies (US$) of Croatia in 2004 and the Aid flow from UN agencies (US$) of Kyrgyz Republic in 2006?
Give a very brief answer. 3.79e+06. What is the difference between the Aid flow from UN agencies (US$) in Croatia in 2004 and the Aid flow from UN agencies (US$) in Zambia in 2006?
Make the answer very short. 2.68e+06. What is the difference between the Aid flow from UN agencies (US$) in Kyrgyz Republic in 2004 and the Aid flow from UN agencies (US$) in Zambia in 2006?
Ensure brevity in your answer.  -7.40e+05. What is the difference between the Aid flow from UN agencies (US$) in Least developed countries in 2004 and the Aid flow from UN agencies (US$) in Croatia in 2007?
Your response must be concise. 1.62e+08. What is the difference between the Aid flow from UN agencies (US$) of Least developed countries in 2004 and the Aid flow from UN agencies (US$) of Kyrgyz Republic in 2007?
Ensure brevity in your answer.  1.63e+08. What is the difference between the Aid flow from UN agencies (US$) in Least developed countries in 2004 and the Aid flow from UN agencies (US$) in Zambia in 2007?
Your answer should be very brief. 1.61e+08. What is the difference between the Aid flow from UN agencies (US$) in Croatia in 2004 and the Aid flow from UN agencies (US$) in Kyrgyz Republic in 2007?
Give a very brief answer. 3.85e+06. What is the difference between the Aid flow from UN agencies (US$) in Croatia in 2004 and the Aid flow from UN agencies (US$) in Zambia in 2007?
Provide a succinct answer. 1.92e+06. What is the difference between the Aid flow from UN agencies (US$) in Kyrgyz Republic in 2004 and the Aid flow from UN agencies (US$) in Zambia in 2007?
Provide a succinct answer. -1.50e+06. What is the difference between the Aid flow from UN agencies (US$) of Least developed countries in 2004 and the Aid flow from UN agencies (US$) of Croatia in 2008?
Provide a succinct answer. 1.62e+08. What is the difference between the Aid flow from UN agencies (US$) in Least developed countries in 2004 and the Aid flow from UN agencies (US$) in Kyrgyz Republic in 2008?
Your answer should be compact. 1.63e+08. What is the difference between the Aid flow from UN agencies (US$) in Least developed countries in 2004 and the Aid flow from UN agencies (US$) in Zambia in 2008?
Give a very brief answer. 1.61e+08. What is the difference between the Aid flow from UN agencies (US$) in Croatia in 2004 and the Aid flow from UN agencies (US$) in Kyrgyz Republic in 2008?
Make the answer very short. 3.68e+06. What is the difference between the Aid flow from UN agencies (US$) in Croatia in 2004 and the Aid flow from UN agencies (US$) in Zambia in 2008?
Ensure brevity in your answer.  1.38e+06. What is the difference between the Aid flow from UN agencies (US$) in Kyrgyz Republic in 2004 and the Aid flow from UN agencies (US$) in Zambia in 2008?
Offer a very short reply. -2.04e+06. What is the difference between the Aid flow from UN agencies (US$) of Least developed countries in 2004 and the Aid flow from UN agencies (US$) of Croatia in 2009?
Offer a terse response. 1.63e+08. What is the difference between the Aid flow from UN agencies (US$) in Least developed countries in 2004 and the Aid flow from UN agencies (US$) in Kyrgyz Republic in 2009?
Make the answer very short. 1.64e+08. What is the difference between the Aid flow from UN agencies (US$) in Least developed countries in 2004 and the Aid flow from UN agencies (US$) in Zambia in 2009?
Offer a very short reply. 1.60e+08. What is the difference between the Aid flow from UN agencies (US$) in Croatia in 2004 and the Aid flow from UN agencies (US$) in Kyrgyz Republic in 2009?
Offer a terse response. 4.14e+06. What is the difference between the Aid flow from UN agencies (US$) of Croatia in 2004 and the Aid flow from UN agencies (US$) of Zambia in 2009?
Your response must be concise. 8.00e+05. What is the difference between the Aid flow from UN agencies (US$) in Kyrgyz Republic in 2004 and the Aid flow from UN agencies (US$) in Zambia in 2009?
Provide a short and direct response. -2.62e+06. What is the difference between the Aid flow from UN agencies (US$) in Least developed countries in 2005 and the Aid flow from UN agencies (US$) in Croatia in 2006?
Give a very brief answer. 4.46e+07. What is the difference between the Aid flow from UN agencies (US$) of Least developed countries in 2005 and the Aid flow from UN agencies (US$) of Kyrgyz Republic in 2006?
Provide a short and direct response. 4.52e+07. What is the difference between the Aid flow from UN agencies (US$) of Least developed countries in 2005 and the Aid flow from UN agencies (US$) of Zambia in 2006?
Your response must be concise. 4.41e+07. What is the difference between the Aid flow from UN agencies (US$) of Croatia in 2005 and the Aid flow from UN agencies (US$) of Kyrgyz Republic in 2006?
Provide a succinct answer. 9.00e+05. What is the difference between the Aid flow from UN agencies (US$) in Kyrgyz Republic in 2005 and the Aid flow from UN agencies (US$) in Zambia in 2006?
Offer a terse response. -3.50e+05. What is the difference between the Aid flow from UN agencies (US$) of Least developed countries in 2005 and the Aid flow from UN agencies (US$) of Croatia in 2007?
Provide a succinct answer. 4.42e+07. What is the difference between the Aid flow from UN agencies (US$) of Least developed countries in 2005 and the Aid flow from UN agencies (US$) of Kyrgyz Republic in 2007?
Make the answer very short. 4.53e+07. What is the difference between the Aid flow from UN agencies (US$) of Least developed countries in 2005 and the Aid flow from UN agencies (US$) of Zambia in 2007?
Your response must be concise. 4.34e+07. What is the difference between the Aid flow from UN agencies (US$) in Croatia in 2005 and the Aid flow from UN agencies (US$) in Kyrgyz Republic in 2007?
Keep it short and to the point. 9.60e+05. What is the difference between the Aid flow from UN agencies (US$) of Croatia in 2005 and the Aid flow from UN agencies (US$) of Zambia in 2007?
Make the answer very short. -9.70e+05. What is the difference between the Aid flow from UN agencies (US$) of Kyrgyz Republic in 2005 and the Aid flow from UN agencies (US$) of Zambia in 2007?
Offer a very short reply. -1.11e+06. What is the difference between the Aid flow from UN agencies (US$) in Least developed countries in 2005 and the Aid flow from UN agencies (US$) in Croatia in 2008?
Offer a terse response. 4.38e+07. What is the difference between the Aid flow from UN agencies (US$) of Least developed countries in 2005 and the Aid flow from UN agencies (US$) of Kyrgyz Republic in 2008?
Give a very brief answer. 4.51e+07. What is the difference between the Aid flow from UN agencies (US$) of Least developed countries in 2005 and the Aid flow from UN agencies (US$) of Zambia in 2008?
Make the answer very short. 4.28e+07. What is the difference between the Aid flow from UN agencies (US$) of Croatia in 2005 and the Aid flow from UN agencies (US$) of Kyrgyz Republic in 2008?
Provide a short and direct response. 7.90e+05. What is the difference between the Aid flow from UN agencies (US$) in Croatia in 2005 and the Aid flow from UN agencies (US$) in Zambia in 2008?
Give a very brief answer. -1.51e+06. What is the difference between the Aid flow from UN agencies (US$) in Kyrgyz Republic in 2005 and the Aid flow from UN agencies (US$) in Zambia in 2008?
Give a very brief answer. -1.65e+06. What is the difference between the Aid flow from UN agencies (US$) of Least developed countries in 2005 and the Aid flow from UN agencies (US$) of Croatia in 2009?
Provide a short and direct response. 4.48e+07. What is the difference between the Aid flow from UN agencies (US$) of Least developed countries in 2005 and the Aid flow from UN agencies (US$) of Kyrgyz Republic in 2009?
Provide a short and direct response. 4.56e+07. What is the difference between the Aid flow from UN agencies (US$) of Least developed countries in 2005 and the Aid flow from UN agencies (US$) of Zambia in 2009?
Give a very brief answer. 4.22e+07. What is the difference between the Aid flow from UN agencies (US$) of Croatia in 2005 and the Aid flow from UN agencies (US$) of Kyrgyz Republic in 2009?
Give a very brief answer. 1.25e+06. What is the difference between the Aid flow from UN agencies (US$) in Croatia in 2005 and the Aid flow from UN agencies (US$) in Zambia in 2009?
Give a very brief answer. -2.09e+06. What is the difference between the Aid flow from UN agencies (US$) in Kyrgyz Republic in 2005 and the Aid flow from UN agencies (US$) in Zambia in 2009?
Ensure brevity in your answer.  -2.23e+06. What is the difference between the Aid flow from UN agencies (US$) in Least developed countries in 2006 and the Aid flow from UN agencies (US$) in Croatia in 2007?
Give a very brief answer. 2.34e+07. What is the difference between the Aid flow from UN agencies (US$) in Least developed countries in 2006 and the Aid flow from UN agencies (US$) in Kyrgyz Republic in 2007?
Ensure brevity in your answer.  2.45e+07. What is the difference between the Aid flow from UN agencies (US$) in Least developed countries in 2006 and the Aid flow from UN agencies (US$) in Zambia in 2007?
Offer a terse response. 2.26e+07. What is the difference between the Aid flow from UN agencies (US$) in Croatia in 2006 and the Aid flow from UN agencies (US$) in Kyrgyz Republic in 2007?
Your answer should be very brief. 7.30e+05. What is the difference between the Aid flow from UN agencies (US$) of Croatia in 2006 and the Aid flow from UN agencies (US$) of Zambia in 2007?
Ensure brevity in your answer.  -1.20e+06. What is the difference between the Aid flow from UN agencies (US$) of Kyrgyz Republic in 2006 and the Aid flow from UN agencies (US$) of Zambia in 2007?
Your response must be concise. -1.87e+06. What is the difference between the Aid flow from UN agencies (US$) of Least developed countries in 2006 and the Aid flow from UN agencies (US$) of Croatia in 2008?
Make the answer very short. 2.30e+07. What is the difference between the Aid flow from UN agencies (US$) in Least developed countries in 2006 and the Aid flow from UN agencies (US$) in Kyrgyz Republic in 2008?
Your answer should be very brief. 2.43e+07. What is the difference between the Aid flow from UN agencies (US$) of Least developed countries in 2006 and the Aid flow from UN agencies (US$) of Zambia in 2008?
Offer a very short reply. 2.20e+07. What is the difference between the Aid flow from UN agencies (US$) of Croatia in 2006 and the Aid flow from UN agencies (US$) of Kyrgyz Republic in 2008?
Make the answer very short. 5.60e+05. What is the difference between the Aid flow from UN agencies (US$) in Croatia in 2006 and the Aid flow from UN agencies (US$) in Zambia in 2008?
Give a very brief answer. -1.74e+06. What is the difference between the Aid flow from UN agencies (US$) of Kyrgyz Republic in 2006 and the Aid flow from UN agencies (US$) of Zambia in 2008?
Keep it short and to the point. -2.41e+06. What is the difference between the Aid flow from UN agencies (US$) in Least developed countries in 2006 and the Aid flow from UN agencies (US$) in Croatia in 2009?
Give a very brief answer. 2.40e+07. What is the difference between the Aid flow from UN agencies (US$) of Least developed countries in 2006 and the Aid flow from UN agencies (US$) of Kyrgyz Republic in 2009?
Give a very brief answer. 2.48e+07. What is the difference between the Aid flow from UN agencies (US$) in Least developed countries in 2006 and the Aid flow from UN agencies (US$) in Zambia in 2009?
Make the answer very short. 2.14e+07. What is the difference between the Aid flow from UN agencies (US$) in Croatia in 2006 and the Aid flow from UN agencies (US$) in Kyrgyz Republic in 2009?
Keep it short and to the point. 1.02e+06. What is the difference between the Aid flow from UN agencies (US$) of Croatia in 2006 and the Aid flow from UN agencies (US$) of Zambia in 2009?
Keep it short and to the point. -2.32e+06. What is the difference between the Aid flow from UN agencies (US$) in Kyrgyz Republic in 2006 and the Aid flow from UN agencies (US$) in Zambia in 2009?
Ensure brevity in your answer.  -2.99e+06. What is the difference between the Aid flow from UN agencies (US$) of Least developed countries in 2007 and the Aid flow from UN agencies (US$) of Croatia in 2008?
Provide a short and direct response. 3.59e+07. What is the difference between the Aid flow from UN agencies (US$) in Least developed countries in 2007 and the Aid flow from UN agencies (US$) in Kyrgyz Republic in 2008?
Make the answer very short. 3.72e+07. What is the difference between the Aid flow from UN agencies (US$) of Least developed countries in 2007 and the Aid flow from UN agencies (US$) of Zambia in 2008?
Offer a very short reply. 3.49e+07. What is the difference between the Aid flow from UN agencies (US$) of Croatia in 2007 and the Aid flow from UN agencies (US$) of Kyrgyz Republic in 2008?
Offer a very short reply. 9.60e+05. What is the difference between the Aid flow from UN agencies (US$) of Croatia in 2007 and the Aid flow from UN agencies (US$) of Zambia in 2008?
Your response must be concise. -1.34e+06. What is the difference between the Aid flow from UN agencies (US$) of Kyrgyz Republic in 2007 and the Aid flow from UN agencies (US$) of Zambia in 2008?
Your answer should be very brief. -2.47e+06. What is the difference between the Aid flow from UN agencies (US$) of Least developed countries in 2007 and the Aid flow from UN agencies (US$) of Croatia in 2009?
Keep it short and to the point. 3.68e+07. What is the difference between the Aid flow from UN agencies (US$) in Least developed countries in 2007 and the Aid flow from UN agencies (US$) in Kyrgyz Republic in 2009?
Your answer should be very brief. 3.76e+07. What is the difference between the Aid flow from UN agencies (US$) in Least developed countries in 2007 and the Aid flow from UN agencies (US$) in Zambia in 2009?
Offer a very short reply. 3.43e+07. What is the difference between the Aid flow from UN agencies (US$) of Croatia in 2007 and the Aid flow from UN agencies (US$) of Kyrgyz Republic in 2009?
Provide a succinct answer. 1.42e+06. What is the difference between the Aid flow from UN agencies (US$) in Croatia in 2007 and the Aid flow from UN agencies (US$) in Zambia in 2009?
Provide a short and direct response. -1.92e+06. What is the difference between the Aid flow from UN agencies (US$) of Kyrgyz Republic in 2007 and the Aid flow from UN agencies (US$) of Zambia in 2009?
Ensure brevity in your answer.  -3.05e+06. What is the difference between the Aid flow from UN agencies (US$) in Least developed countries in 2008 and the Aid flow from UN agencies (US$) in Croatia in 2009?
Ensure brevity in your answer.  4.30e+07. What is the difference between the Aid flow from UN agencies (US$) in Least developed countries in 2008 and the Aid flow from UN agencies (US$) in Kyrgyz Republic in 2009?
Provide a short and direct response. 4.38e+07. What is the difference between the Aid flow from UN agencies (US$) of Least developed countries in 2008 and the Aid flow from UN agencies (US$) of Zambia in 2009?
Ensure brevity in your answer.  4.05e+07. What is the difference between the Aid flow from UN agencies (US$) in Croatia in 2008 and the Aid flow from UN agencies (US$) in Kyrgyz Republic in 2009?
Offer a very short reply. 1.75e+06. What is the difference between the Aid flow from UN agencies (US$) in Croatia in 2008 and the Aid flow from UN agencies (US$) in Zambia in 2009?
Make the answer very short. -1.59e+06. What is the difference between the Aid flow from UN agencies (US$) in Kyrgyz Republic in 2008 and the Aid flow from UN agencies (US$) in Zambia in 2009?
Offer a very short reply. -2.88e+06. What is the average Aid flow from UN agencies (US$) in Least developed countries per year?
Offer a very short reply. 1.05e+08. What is the average Aid flow from UN agencies (US$) of Croatia per year?
Ensure brevity in your answer.  3.60e+06. What is the average Aid flow from UN agencies (US$) in Kyrgyz Republic per year?
Make the answer very short. 8.65e+05. What is the average Aid flow from UN agencies (US$) of Zambia per year?
Your answer should be compact. 6.38e+06. In the year 2002, what is the difference between the Aid flow from UN agencies (US$) in Least developed countries and Aid flow from UN agencies (US$) in Croatia?
Offer a terse response. 2.45e+08. In the year 2002, what is the difference between the Aid flow from UN agencies (US$) in Least developed countries and Aid flow from UN agencies (US$) in Kyrgyz Republic?
Your answer should be very brief. 2.54e+08. In the year 2002, what is the difference between the Aid flow from UN agencies (US$) in Least developed countries and Aid flow from UN agencies (US$) in Zambia?
Offer a very short reply. 2.39e+08. In the year 2002, what is the difference between the Aid flow from UN agencies (US$) of Croatia and Aid flow from UN agencies (US$) of Kyrgyz Republic?
Ensure brevity in your answer.  8.53e+06. In the year 2002, what is the difference between the Aid flow from UN agencies (US$) of Croatia and Aid flow from UN agencies (US$) of Zambia?
Make the answer very short. -6.60e+06. In the year 2002, what is the difference between the Aid flow from UN agencies (US$) in Kyrgyz Republic and Aid flow from UN agencies (US$) in Zambia?
Provide a succinct answer. -1.51e+07. In the year 2003, what is the difference between the Aid flow from UN agencies (US$) of Least developed countries and Aid flow from UN agencies (US$) of Croatia?
Your answer should be very brief. 1.97e+08. In the year 2003, what is the difference between the Aid flow from UN agencies (US$) of Least developed countries and Aid flow from UN agencies (US$) of Kyrgyz Republic?
Your answer should be compact. 2.03e+08. In the year 2003, what is the difference between the Aid flow from UN agencies (US$) in Least developed countries and Aid flow from UN agencies (US$) in Zambia?
Ensure brevity in your answer.  1.92e+08. In the year 2003, what is the difference between the Aid flow from UN agencies (US$) of Croatia and Aid flow from UN agencies (US$) of Kyrgyz Republic?
Offer a terse response. 5.87e+06. In the year 2003, what is the difference between the Aid flow from UN agencies (US$) in Croatia and Aid flow from UN agencies (US$) in Zambia?
Ensure brevity in your answer.  -4.39e+06. In the year 2003, what is the difference between the Aid flow from UN agencies (US$) in Kyrgyz Republic and Aid flow from UN agencies (US$) in Zambia?
Make the answer very short. -1.03e+07. In the year 2004, what is the difference between the Aid flow from UN agencies (US$) of Least developed countries and Aid flow from UN agencies (US$) of Croatia?
Provide a succinct answer. 1.60e+08. In the year 2004, what is the difference between the Aid flow from UN agencies (US$) of Least developed countries and Aid flow from UN agencies (US$) of Kyrgyz Republic?
Provide a succinct answer. 1.63e+08. In the year 2004, what is the difference between the Aid flow from UN agencies (US$) in Least developed countries and Aid flow from UN agencies (US$) in Zambia?
Offer a terse response. 1.54e+08. In the year 2004, what is the difference between the Aid flow from UN agencies (US$) in Croatia and Aid flow from UN agencies (US$) in Kyrgyz Republic?
Keep it short and to the point. 3.42e+06. In the year 2004, what is the difference between the Aid flow from UN agencies (US$) of Croatia and Aid flow from UN agencies (US$) of Zambia?
Offer a terse response. -5.91e+06. In the year 2004, what is the difference between the Aid flow from UN agencies (US$) of Kyrgyz Republic and Aid flow from UN agencies (US$) of Zambia?
Offer a terse response. -9.33e+06. In the year 2005, what is the difference between the Aid flow from UN agencies (US$) of Least developed countries and Aid flow from UN agencies (US$) of Croatia?
Make the answer very short. 4.43e+07. In the year 2005, what is the difference between the Aid flow from UN agencies (US$) of Least developed countries and Aid flow from UN agencies (US$) of Kyrgyz Republic?
Provide a succinct answer. 4.45e+07. In the year 2005, what is the difference between the Aid flow from UN agencies (US$) of Least developed countries and Aid flow from UN agencies (US$) of Zambia?
Your answer should be very brief. 4.37e+07. In the year 2005, what is the difference between the Aid flow from UN agencies (US$) of Croatia and Aid flow from UN agencies (US$) of Zambia?
Give a very brief answer. -6.10e+05. In the year 2005, what is the difference between the Aid flow from UN agencies (US$) in Kyrgyz Republic and Aid flow from UN agencies (US$) in Zambia?
Offer a very short reply. -7.50e+05. In the year 2006, what is the difference between the Aid flow from UN agencies (US$) in Least developed countries and Aid flow from UN agencies (US$) in Croatia?
Give a very brief answer. 2.38e+07. In the year 2006, what is the difference between the Aid flow from UN agencies (US$) of Least developed countries and Aid flow from UN agencies (US$) of Kyrgyz Republic?
Ensure brevity in your answer.  2.44e+07. In the year 2006, what is the difference between the Aid flow from UN agencies (US$) in Least developed countries and Aid flow from UN agencies (US$) in Zambia?
Provide a short and direct response. 2.33e+07. In the year 2006, what is the difference between the Aid flow from UN agencies (US$) in Croatia and Aid flow from UN agencies (US$) in Kyrgyz Republic?
Provide a succinct answer. 6.70e+05. In the year 2006, what is the difference between the Aid flow from UN agencies (US$) in Croatia and Aid flow from UN agencies (US$) in Zambia?
Offer a very short reply. -4.40e+05. In the year 2006, what is the difference between the Aid flow from UN agencies (US$) in Kyrgyz Republic and Aid flow from UN agencies (US$) in Zambia?
Provide a short and direct response. -1.11e+06. In the year 2007, what is the difference between the Aid flow from UN agencies (US$) of Least developed countries and Aid flow from UN agencies (US$) of Croatia?
Ensure brevity in your answer.  3.62e+07. In the year 2007, what is the difference between the Aid flow from UN agencies (US$) of Least developed countries and Aid flow from UN agencies (US$) of Kyrgyz Republic?
Provide a short and direct response. 3.74e+07. In the year 2007, what is the difference between the Aid flow from UN agencies (US$) of Least developed countries and Aid flow from UN agencies (US$) of Zambia?
Your answer should be compact. 3.54e+07. In the year 2007, what is the difference between the Aid flow from UN agencies (US$) in Croatia and Aid flow from UN agencies (US$) in Kyrgyz Republic?
Offer a terse response. 1.13e+06. In the year 2007, what is the difference between the Aid flow from UN agencies (US$) in Croatia and Aid flow from UN agencies (US$) in Zambia?
Your answer should be compact. -8.00e+05. In the year 2007, what is the difference between the Aid flow from UN agencies (US$) in Kyrgyz Republic and Aid flow from UN agencies (US$) in Zambia?
Ensure brevity in your answer.  -1.93e+06. In the year 2008, what is the difference between the Aid flow from UN agencies (US$) in Least developed countries and Aid flow from UN agencies (US$) in Croatia?
Your answer should be very brief. 4.21e+07. In the year 2008, what is the difference between the Aid flow from UN agencies (US$) of Least developed countries and Aid flow from UN agencies (US$) of Kyrgyz Republic?
Your answer should be very brief. 4.34e+07. In the year 2008, what is the difference between the Aid flow from UN agencies (US$) of Least developed countries and Aid flow from UN agencies (US$) of Zambia?
Your answer should be compact. 4.11e+07. In the year 2008, what is the difference between the Aid flow from UN agencies (US$) in Croatia and Aid flow from UN agencies (US$) in Kyrgyz Republic?
Offer a terse response. 1.29e+06. In the year 2008, what is the difference between the Aid flow from UN agencies (US$) in Croatia and Aid flow from UN agencies (US$) in Zambia?
Your answer should be compact. -1.01e+06. In the year 2008, what is the difference between the Aid flow from UN agencies (US$) in Kyrgyz Republic and Aid flow from UN agencies (US$) in Zambia?
Make the answer very short. -2.30e+06. In the year 2009, what is the difference between the Aid flow from UN agencies (US$) of Least developed countries and Aid flow from UN agencies (US$) of Croatia?
Provide a short and direct response. 6.48e+07. In the year 2009, what is the difference between the Aid flow from UN agencies (US$) in Least developed countries and Aid flow from UN agencies (US$) in Kyrgyz Republic?
Provide a short and direct response. 6.56e+07. In the year 2009, what is the difference between the Aid flow from UN agencies (US$) of Least developed countries and Aid flow from UN agencies (US$) of Zambia?
Offer a terse response. 6.23e+07. In the year 2009, what is the difference between the Aid flow from UN agencies (US$) of Croatia and Aid flow from UN agencies (US$) of Kyrgyz Republic?
Provide a succinct answer. 8.20e+05. In the year 2009, what is the difference between the Aid flow from UN agencies (US$) in Croatia and Aid flow from UN agencies (US$) in Zambia?
Your answer should be very brief. -2.52e+06. In the year 2009, what is the difference between the Aid flow from UN agencies (US$) in Kyrgyz Republic and Aid flow from UN agencies (US$) in Zambia?
Make the answer very short. -3.34e+06. What is the ratio of the Aid flow from UN agencies (US$) in Least developed countries in 2002 to that in 2003?
Offer a terse response. 1.25. What is the ratio of the Aid flow from UN agencies (US$) of Croatia in 2002 to that in 2003?
Ensure brevity in your answer.  1.4. What is the ratio of the Aid flow from UN agencies (US$) in Kyrgyz Republic in 2002 to that in 2003?
Make the answer very short. 1.03. What is the ratio of the Aid flow from UN agencies (US$) in Zambia in 2002 to that in 2003?
Make the answer very short. 1.44. What is the ratio of the Aid flow from UN agencies (US$) in Least developed countries in 2002 to that in 2004?
Make the answer very short. 1.55. What is the ratio of the Aid flow from UN agencies (US$) in Croatia in 2002 to that in 2004?
Ensure brevity in your answer.  2.1. What is the ratio of the Aid flow from UN agencies (US$) in Kyrgyz Republic in 2002 to that in 2004?
Provide a short and direct response. 0.86. What is the ratio of the Aid flow from UN agencies (US$) of Zambia in 2002 to that in 2004?
Make the answer very short. 1.54. What is the ratio of the Aid flow from UN agencies (US$) in Least developed countries in 2002 to that in 2005?
Make the answer very short. 5.55. What is the ratio of the Aid flow from UN agencies (US$) in Croatia in 2002 to that in 2005?
Keep it short and to the point. 5.88. What is the ratio of the Aid flow from UN agencies (US$) of Kyrgyz Republic in 2002 to that in 2005?
Your answer should be very brief. 0.63. What is the ratio of the Aid flow from UN agencies (US$) of Zambia in 2002 to that in 2005?
Make the answer very short. 7.23. What is the ratio of the Aid flow from UN agencies (US$) in Least developed countries in 2002 to that in 2006?
Provide a short and direct response. 10.14. What is the ratio of the Aid flow from UN agencies (US$) of Croatia in 2002 to that in 2006?
Ensure brevity in your answer.  6.86. What is the ratio of the Aid flow from UN agencies (US$) of Kyrgyz Republic in 2002 to that in 2006?
Offer a very short reply. 1.31. What is the ratio of the Aid flow from UN agencies (US$) in Zambia in 2002 to that in 2006?
Provide a succinct answer. 8.82. What is the ratio of the Aid flow from UN agencies (US$) in Least developed countries in 2002 to that in 2007?
Keep it short and to the point. 6.71. What is the ratio of the Aid flow from UN agencies (US$) in Croatia in 2002 to that in 2007?
Give a very brief answer. 5.31. What is the ratio of the Aid flow from UN agencies (US$) of Kyrgyz Republic in 2002 to that in 2007?
Make the answer very short. 1.43. What is the ratio of the Aid flow from UN agencies (US$) of Zambia in 2002 to that in 2007?
Ensure brevity in your answer.  6.22. What is the ratio of the Aid flow from UN agencies (US$) of Least developed countries in 2002 to that in 2008?
Your answer should be compact. 5.77. What is the ratio of the Aid flow from UN agencies (US$) of Croatia in 2002 to that in 2008?
Your response must be concise. 4.48. What is the ratio of the Aid flow from UN agencies (US$) of Kyrgyz Republic in 2002 to that in 2008?
Give a very brief answer. 1.13. What is the ratio of the Aid flow from UN agencies (US$) of Zambia in 2002 to that in 2008?
Provide a short and direct response. 5.15. What is the ratio of the Aid flow from UN agencies (US$) in Least developed countries in 2002 to that in 2009?
Keep it short and to the point. 3.87. What is the ratio of the Aid flow from UN agencies (US$) in Croatia in 2002 to that in 2009?
Offer a very short reply. 8.02. What is the ratio of the Aid flow from UN agencies (US$) of Kyrgyz Republic in 2002 to that in 2009?
Keep it short and to the point. 2.58. What is the ratio of the Aid flow from UN agencies (US$) in Zambia in 2002 to that in 2009?
Your answer should be compact. 4.34. What is the ratio of the Aid flow from UN agencies (US$) of Least developed countries in 2003 to that in 2004?
Make the answer very short. 1.24. What is the ratio of the Aid flow from UN agencies (US$) of Croatia in 2003 to that in 2004?
Keep it short and to the point. 1.5. What is the ratio of the Aid flow from UN agencies (US$) in Zambia in 2003 to that in 2004?
Make the answer very short. 1.07. What is the ratio of the Aid flow from UN agencies (US$) of Least developed countries in 2003 to that in 2005?
Provide a short and direct response. 4.43. What is the ratio of the Aid flow from UN agencies (US$) of Croatia in 2003 to that in 2005?
Provide a succinct answer. 4.21. What is the ratio of the Aid flow from UN agencies (US$) in Kyrgyz Republic in 2003 to that in 2005?
Provide a succinct answer. 0.61. What is the ratio of the Aid flow from UN agencies (US$) in Zambia in 2003 to that in 2005?
Provide a succinct answer. 5.03. What is the ratio of the Aid flow from UN agencies (US$) of Least developed countries in 2003 to that in 2006?
Keep it short and to the point. 8.1. What is the ratio of the Aid flow from UN agencies (US$) of Croatia in 2003 to that in 2006?
Provide a short and direct response. 4.91. What is the ratio of the Aid flow from UN agencies (US$) in Kyrgyz Republic in 2003 to that in 2006?
Make the answer very short. 1.27. What is the ratio of the Aid flow from UN agencies (US$) of Zambia in 2003 to that in 2006?
Your answer should be very brief. 6.13. What is the ratio of the Aid flow from UN agencies (US$) of Least developed countries in 2003 to that in 2007?
Keep it short and to the point. 5.35. What is the ratio of the Aid flow from UN agencies (US$) of Croatia in 2003 to that in 2007?
Provide a succinct answer. 3.8. What is the ratio of the Aid flow from UN agencies (US$) in Kyrgyz Republic in 2003 to that in 2007?
Offer a very short reply. 1.38. What is the ratio of the Aid flow from UN agencies (US$) in Zambia in 2003 to that in 2007?
Give a very brief answer. 4.33. What is the ratio of the Aid flow from UN agencies (US$) in Least developed countries in 2003 to that in 2008?
Your answer should be very brief. 4.6. What is the ratio of the Aid flow from UN agencies (US$) in Croatia in 2003 to that in 2008?
Provide a succinct answer. 3.21. What is the ratio of the Aid flow from UN agencies (US$) in Kyrgyz Republic in 2003 to that in 2008?
Keep it short and to the point. 1.1. What is the ratio of the Aid flow from UN agencies (US$) of Zambia in 2003 to that in 2008?
Keep it short and to the point. 3.58. What is the ratio of the Aid flow from UN agencies (US$) in Least developed countries in 2003 to that in 2009?
Keep it short and to the point. 3.08. What is the ratio of the Aid flow from UN agencies (US$) of Croatia in 2003 to that in 2009?
Your answer should be compact. 5.74. What is the ratio of the Aid flow from UN agencies (US$) in Zambia in 2003 to that in 2009?
Make the answer very short. 3.02. What is the ratio of the Aid flow from UN agencies (US$) in Least developed countries in 2004 to that in 2005?
Keep it short and to the point. 3.57. What is the ratio of the Aid flow from UN agencies (US$) in Croatia in 2004 to that in 2005?
Provide a succinct answer. 2.79. What is the ratio of the Aid flow from UN agencies (US$) of Kyrgyz Republic in 2004 to that in 2005?
Keep it short and to the point. 0.73. What is the ratio of the Aid flow from UN agencies (US$) of Zambia in 2004 to that in 2005?
Your answer should be compact. 4.69. What is the ratio of the Aid flow from UN agencies (US$) of Least developed countries in 2004 to that in 2006?
Offer a terse response. 6.53. What is the ratio of the Aid flow from UN agencies (US$) in Croatia in 2004 to that in 2006?
Ensure brevity in your answer.  3.26. What is the ratio of the Aid flow from UN agencies (US$) in Kyrgyz Republic in 2004 to that in 2006?
Offer a very short reply. 1.52. What is the ratio of the Aid flow from UN agencies (US$) of Zambia in 2004 to that in 2006?
Your response must be concise. 5.72. What is the ratio of the Aid flow from UN agencies (US$) of Least developed countries in 2004 to that in 2007?
Ensure brevity in your answer.  4.32. What is the ratio of the Aid flow from UN agencies (US$) in Croatia in 2004 to that in 2007?
Make the answer very short. 2.53. What is the ratio of the Aid flow from UN agencies (US$) in Kyrgyz Republic in 2004 to that in 2007?
Provide a succinct answer. 1.66. What is the ratio of the Aid flow from UN agencies (US$) in Zambia in 2004 to that in 2007?
Provide a short and direct response. 4.03. What is the ratio of the Aid flow from UN agencies (US$) of Least developed countries in 2004 to that in 2008?
Offer a very short reply. 3.71. What is the ratio of the Aid flow from UN agencies (US$) of Croatia in 2004 to that in 2008?
Provide a succinct answer. 2.13. What is the ratio of the Aid flow from UN agencies (US$) of Kyrgyz Republic in 2004 to that in 2008?
Make the answer very short. 1.32. What is the ratio of the Aid flow from UN agencies (US$) in Zambia in 2004 to that in 2008?
Give a very brief answer. 3.34. What is the ratio of the Aid flow from UN agencies (US$) of Least developed countries in 2004 to that in 2009?
Offer a terse response. 2.49. What is the ratio of the Aid flow from UN agencies (US$) of Croatia in 2004 to that in 2009?
Provide a short and direct response. 3.81. What is the ratio of the Aid flow from UN agencies (US$) of Zambia in 2004 to that in 2009?
Your response must be concise. 2.81. What is the ratio of the Aid flow from UN agencies (US$) of Least developed countries in 2005 to that in 2006?
Your answer should be compact. 1.83. What is the ratio of the Aid flow from UN agencies (US$) in Kyrgyz Republic in 2005 to that in 2006?
Give a very brief answer. 2.07. What is the ratio of the Aid flow from UN agencies (US$) of Zambia in 2005 to that in 2006?
Provide a short and direct response. 1.22. What is the ratio of the Aid flow from UN agencies (US$) in Least developed countries in 2005 to that in 2007?
Make the answer very short. 1.21. What is the ratio of the Aid flow from UN agencies (US$) of Croatia in 2005 to that in 2007?
Your response must be concise. 0.9. What is the ratio of the Aid flow from UN agencies (US$) in Kyrgyz Republic in 2005 to that in 2007?
Make the answer very short. 2.26. What is the ratio of the Aid flow from UN agencies (US$) in Zambia in 2005 to that in 2007?
Make the answer very short. 0.86. What is the ratio of the Aid flow from UN agencies (US$) in Least developed countries in 2005 to that in 2008?
Keep it short and to the point. 1.04. What is the ratio of the Aid flow from UN agencies (US$) in Croatia in 2005 to that in 2008?
Keep it short and to the point. 0.76. What is the ratio of the Aid flow from UN agencies (US$) of Kyrgyz Republic in 2005 to that in 2008?
Your answer should be very brief. 1.79. What is the ratio of the Aid flow from UN agencies (US$) in Zambia in 2005 to that in 2008?
Make the answer very short. 0.71. What is the ratio of the Aid flow from UN agencies (US$) of Least developed countries in 2005 to that in 2009?
Provide a succinct answer. 0.7. What is the ratio of the Aid flow from UN agencies (US$) in Croatia in 2005 to that in 2009?
Keep it short and to the point. 1.36. What is the ratio of the Aid flow from UN agencies (US$) in Kyrgyz Republic in 2005 to that in 2009?
Provide a short and direct response. 4.08. What is the ratio of the Aid flow from UN agencies (US$) in Zambia in 2005 to that in 2009?
Offer a very short reply. 0.6. What is the ratio of the Aid flow from UN agencies (US$) of Least developed countries in 2006 to that in 2007?
Provide a succinct answer. 0.66. What is the ratio of the Aid flow from UN agencies (US$) of Croatia in 2006 to that in 2007?
Provide a succinct answer. 0.78. What is the ratio of the Aid flow from UN agencies (US$) of Kyrgyz Republic in 2006 to that in 2007?
Offer a terse response. 1.09. What is the ratio of the Aid flow from UN agencies (US$) of Zambia in 2006 to that in 2007?
Your answer should be very brief. 0.71. What is the ratio of the Aid flow from UN agencies (US$) in Least developed countries in 2006 to that in 2008?
Offer a terse response. 0.57. What is the ratio of the Aid flow from UN agencies (US$) in Croatia in 2006 to that in 2008?
Your response must be concise. 0.65. What is the ratio of the Aid flow from UN agencies (US$) in Kyrgyz Republic in 2006 to that in 2008?
Your answer should be compact. 0.87. What is the ratio of the Aid flow from UN agencies (US$) in Zambia in 2006 to that in 2008?
Your response must be concise. 0.58. What is the ratio of the Aid flow from UN agencies (US$) of Least developed countries in 2006 to that in 2009?
Make the answer very short. 0.38. What is the ratio of the Aid flow from UN agencies (US$) in Croatia in 2006 to that in 2009?
Your response must be concise. 1.17. What is the ratio of the Aid flow from UN agencies (US$) of Kyrgyz Republic in 2006 to that in 2009?
Your answer should be very brief. 1.97. What is the ratio of the Aid flow from UN agencies (US$) in Zambia in 2006 to that in 2009?
Make the answer very short. 0.49. What is the ratio of the Aid flow from UN agencies (US$) in Least developed countries in 2007 to that in 2008?
Provide a succinct answer. 0.86. What is the ratio of the Aid flow from UN agencies (US$) in Croatia in 2007 to that in 2008?
Provide a succinct answer. 0.84. What is the ratio of the Aid flow from UN agencies (US$) of Kyrgyz Republic in 2007 to that in 2008?
Provide a short and direct response. 0.79. What is the ratio of the Aid flow from UN agencies (US$) of Zambia in 2007 to that in 2008?
Provide a succinct answer. 0.83. What is the ratio of the Aid flow from UN agencies (US$) in Least developed countries in 2007 to that in 2009?
Provide a short and direct response. 0.58. What is the ratio of the Aid flow from UN agencies (US$) of Croatia in 2007 to that in 2009?
Provide a short and direct response. 1.51. What is the ratio of the Aid flow from UN agencies (US$) in Kyrgyz Republic in 2007 to that in 2009?
Your response must be concise. 1.81. What is the ratio of the Aid flow from UN agencies (US$) in Zambia in 2007 to that in 2009?
Your answer should be compact. 0.7. What is the ratio of the Aid flow from UN agencies (US$) of Least developed countries in 2008 to that in 2009?
Your answer should be very brief. 0.67. What is the ratio of the Aid flow from UN agencies (US$) of Croatia in 2008 to that in 2009?
Keep it short and to the point. 1.79. What is the ratio of the Aid flow from UN agencies (US$) of Kyrgyz Republic in 2008 to that in 2009?
Make the answer very short. 2.28. What is the ratio of the Aid flow from UN agencies (US$) of Zambia in 2008 to that in 2009?
Your answer should be very brief. 0.84. What is the difference between the highest and the second highest Aid flow from UN agencies (US$) in Least developed countries?
Your response must be concise. 5.15e+07. What is the difference between the highest and the second highest Aid flow from UN agencies (US$) in Croatia?
Keep it short and to the point. 2.69e+06. What is the difference between the highest and the second highest Aid flow from UN agencies (US$) of Kyrgyz Republic?
Your answer should be very brief. 3.90e+05. What is the difference between the highest and the second highest Aid flow from UN agencies (US$) of Zambia?
Ensure brevity in your answer.  4.90e+06. What is the difference between the highest and the lowest Aid flow from UN agencies (US$) of Least developed countries?
Offer a terse response. 2.30e+08. What is the difference between the highest and the lowest Aid flow from UN agencies (US$) in Croatia?
Keep it short and to the point. 8.28e+06. What is the difference between the highest and the lowest Aid flow from UN agencies (US$) of Kyrgyz Republic?
Your response must be concise. 1.11e+06. What is the difference between the highest and the lowest Aid flow from UN agencies (US$) of Zambia?
Offer a very short reply. 1.42e+07. 